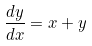Convert formula to latex. <formula><loc_0><loc_0><loc_500><loc_500>\frac { d y } { d x } = x + y</formula> 